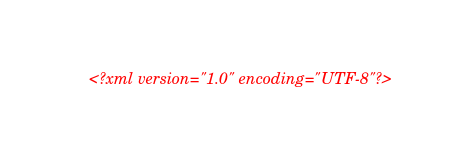<code> <loc_0><loc_0><loc_500><loc_500><_XML_><?xml version="1.0" encoding="UTF-8"?></code> 